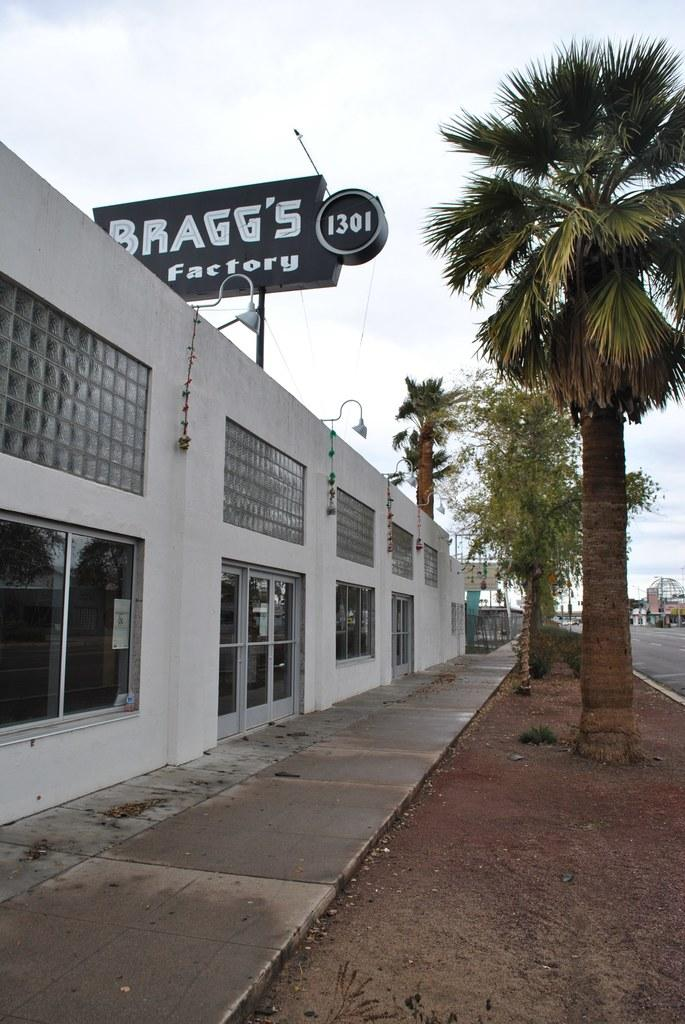What type of structures can be seen in the image? There are buildings in the image. What other elements are present in the area? There are trees in the area. What is on top of one of the buildings? There is a banner on top of a building. What does the banner say? The banner has the text "Braggs Factory" written on it. What type of pie is being served at the educational event in the image? There is no pie or educational event present in the image. 